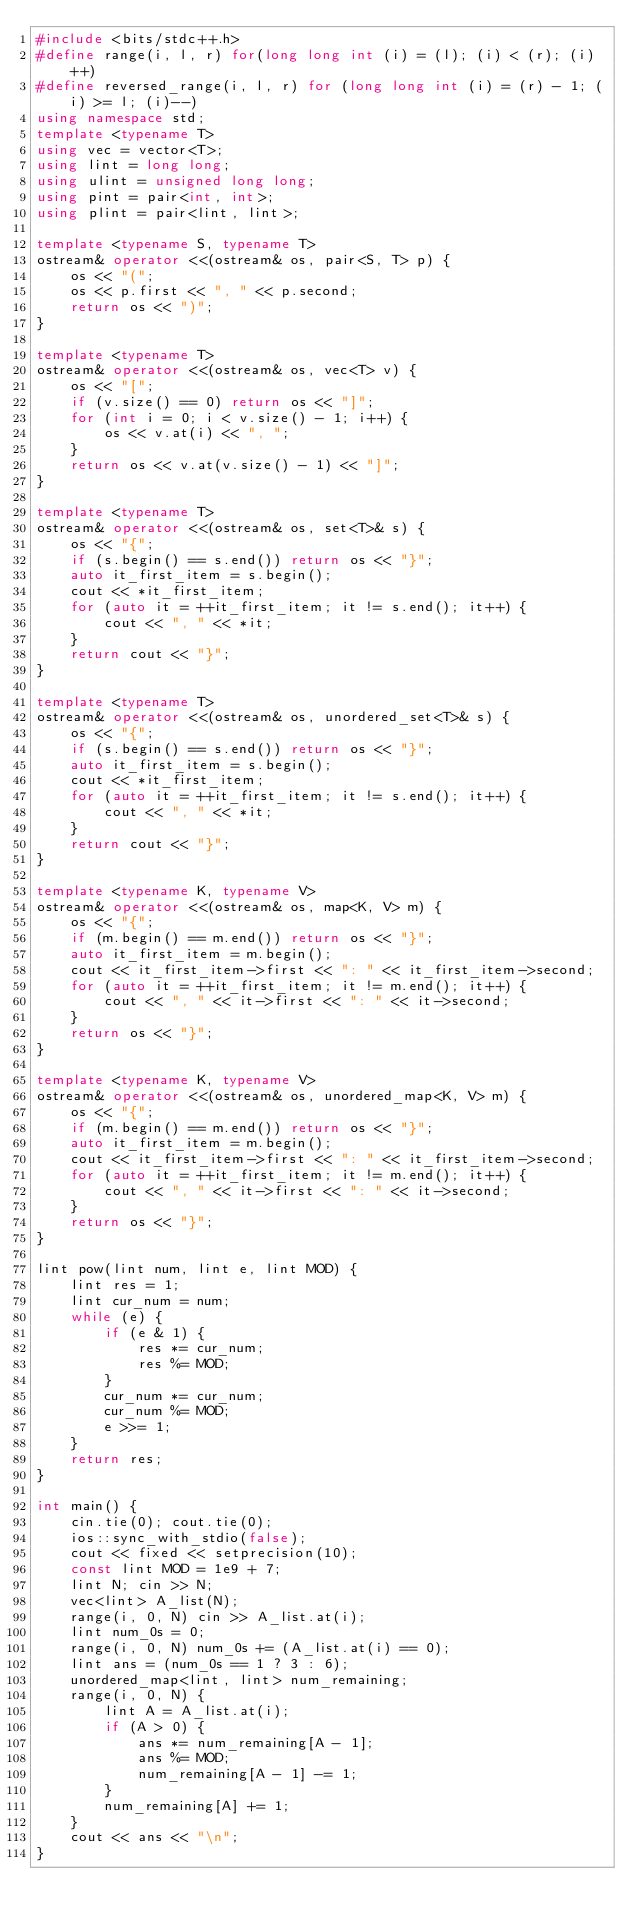<code> <loc_0><loc_0><loc_500><loc_500><_C++_>#include <bits/stdc++.h>
#define range(i, l, r) for(long long int (i) = (l); (i) < (r); (i)++)
#define reversed_range(i, l, r) for (long long int (i) = (r) - 1; (i) >= l; (i)--)
using namespace std;
template <typename T>
using vec = vector<T>;
using lint = long long;
using ulint = unsigned long long;
using pint = pair<int, int>;
using plint = pair<lint, lint>;

template <typename S, typename T>
ostream& operator <<(ostream& os, pair<S, T> p) {
    os << "(";
    os << p.first << ", " << p.second;
    return os << ")";
}

template <typename T>
ostream& operator <<(ostream& os, vec<T> v) {
    os << "[";
    if (v.size() == 0) return os << "]";
    for (int i = 0; i < v.size() - 1; i++) {
        os << v.at(i) << ", ";
    }
    return os << v.at(v.size() - 1) << "]";
}

template <typename T>
ostream& operator <<(ostream& os, set<T>& s) {
    os << "{";
    if (s.begin() == s.end()) return os << "}";
    auto it_first_item = s.begin();
    cout << *it_first_item;
    for (auto it = ++it_first_item; it != s.end(); it++) {
        cout << ", " << *it;
    }
    return cout << "}";
}

template <typename T>
ostream& operator <<(ostream& os, unordered_set<T>& s) {
    os << "{";
    if (s.begin() == s.end()) return os << "}";
    auto it_first_item = s.begin();
    cout << *it_first_item;
    for (auto it = ++it_first_item; it != s.end(); it++) {
        cout << ", " << *it;
    }
    return cout << "}";
}

template <typename K, typename V>
ostream& operator <<(ostream& os, map<K, V> m) {
    os << "{";
    if (m.begin() == m.end()) return os << "}";
    auto it_first_item = m.begin();
    cout << it_first_item->first << ": " << it_first_item->second;
    for (auto it = ++it_first_item; it != m.end(); it++) {
        cout << ", " << it->first << ": " << it->second;
    }
    return os << "}";
}

template <typename K, typename V>
ostream& operator <<(ostream& os, unordered_map<K, V> m) {
    os << "{";
    if (m.begin() == m.end()) return os << "}";
    auto it_first_item = m.begin();
    cout << it_first_item->first << ": " << it_first_item->second;
    for (auto it = ++it_first_item; it != m.end(); it++) {
        cout << ", " << it->first << ": " << it->second;
    }
    return os << "}";
}

lint pow(lint num, lint e, lint MOD) {
    lint res = 1;
    lint cur_num = num;
    while (e) {
        if (e & 1) {
            res *= cur_num;
            res %= MOD;
        }
        cur_num *= cur_num;
        cur_num %= MOD;
        e >>= 1;
    }
    return res;
}

int main() {
    cin.tie(0); cout.tie(0);
    ios::sync_with_stdio(false);
    cout << fixed << setprecision(10);
    const lint MOD = 1e9 + 7;
    lint N; cin >> N;
    vec<lint> A_list(N);
    range(i, 0, N) cin >> A_list.at(i);
    lint num_0s = 0;
    range(i, 0, N) num_0s += (A_list.at(i) == 0);
    lint ans = (num_0s == 1 ? 3 : 6);
    unordered_map<lint, lint> num_remaining;
    range(i, 0, N) {
        lint A = A_list.at(i);
        if (A > 0) {
            ans *= num_remaining[A - 1];
            ans %= MOD;
            num_remaining[A - 1] -= 1;
        }
        num_remaining[A] += 1;
    }
    cout << ans << "\n";
}</code> 